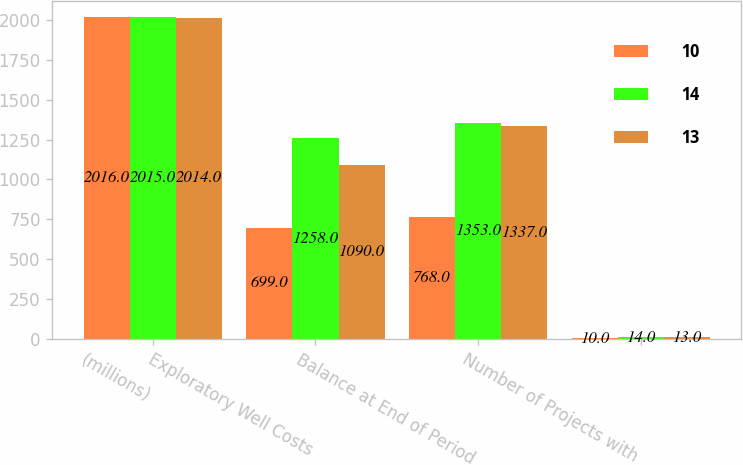<chart> <loc_0><loc_0><loc_500><loc_500><stacked_bar_chart><ecel><fcel>(millions)<fcel>Exploratory Well Costs<fcel>Balance at End of Period<fcel>Number of Projects with<nl><fcel>10<fcel>2016<fcel>699<fcel>768<fcel>10<nl><fcel>14<fcel>2015<fcel>1258<fcel>1353<fcel>14<nl><fcel>13<fcel>2014<fcel>1090<fcel>1337<fcel>13<nl></chart> 